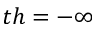Convert formula to latex. <formula><loc_0><loc_0><loc_500><loc_500>t h = - \infty</formula> 